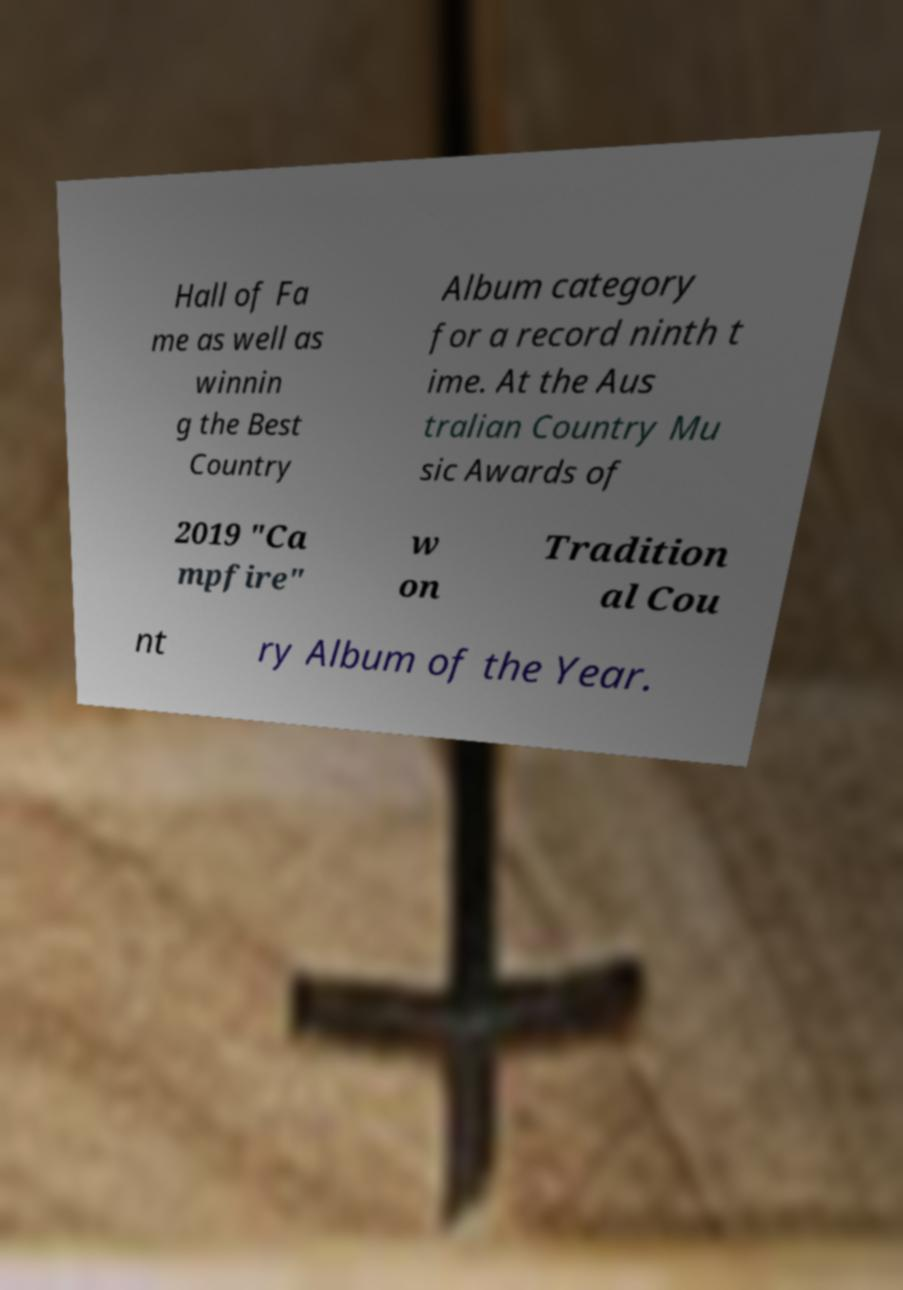There's text embedded in this image that I need extracted. Can you transcribe it verbatim? Hall of Fa me as well as winnin g the Best Country Album category for a record ninth t ime. At the Aus tralian Country Mu sic Awards of 2019 "Ca mpfire" w on Tradition al Cou nt ry Album of the Year. 